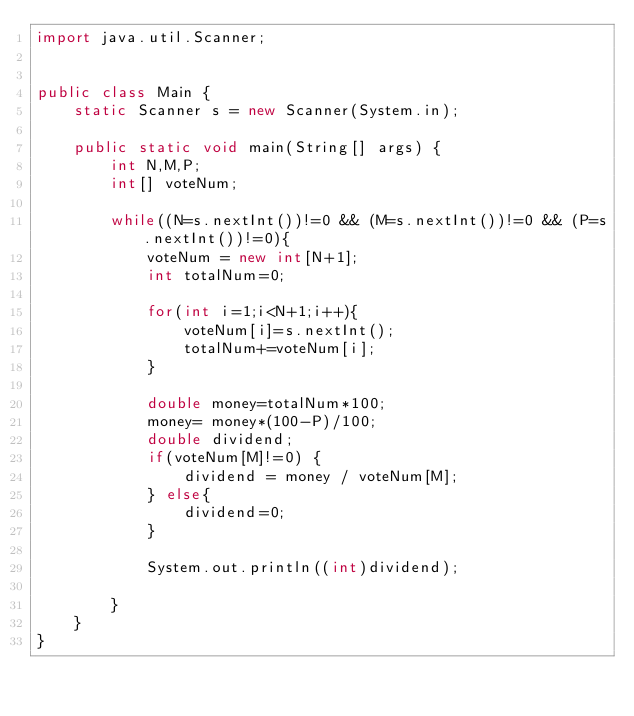<code> <loc_0><loc_0><loc_500><loc_500><_Java_>import java.util.Scanner;


public class Main {
    static Scanner s = new Scanner(System.in);

    public static void main(String[] args) {
        int N,M,P;
        int[] voteNum;

        while((N=s.nextInt())!=0 && (M=s.nextInt())!=0 && (P=s.nextInt())!=0){
            voteNum = new int[N+1];
            int totalNum=0;

            for(int i=1;i<N+1;i++){
                voteNum[i]=s.nextInt();
                totalNum+=voteNum[i];
            }

            double money=totalNum*100;
            money= money*(100-P)/100;
            double dividend;
            if(voteNum[M]!=0) {
                dividend = money / voteNum[M];
            } else{
                dividend=0;
            }

            System.out.println((int)dividend);

        }
    }
}</code> 